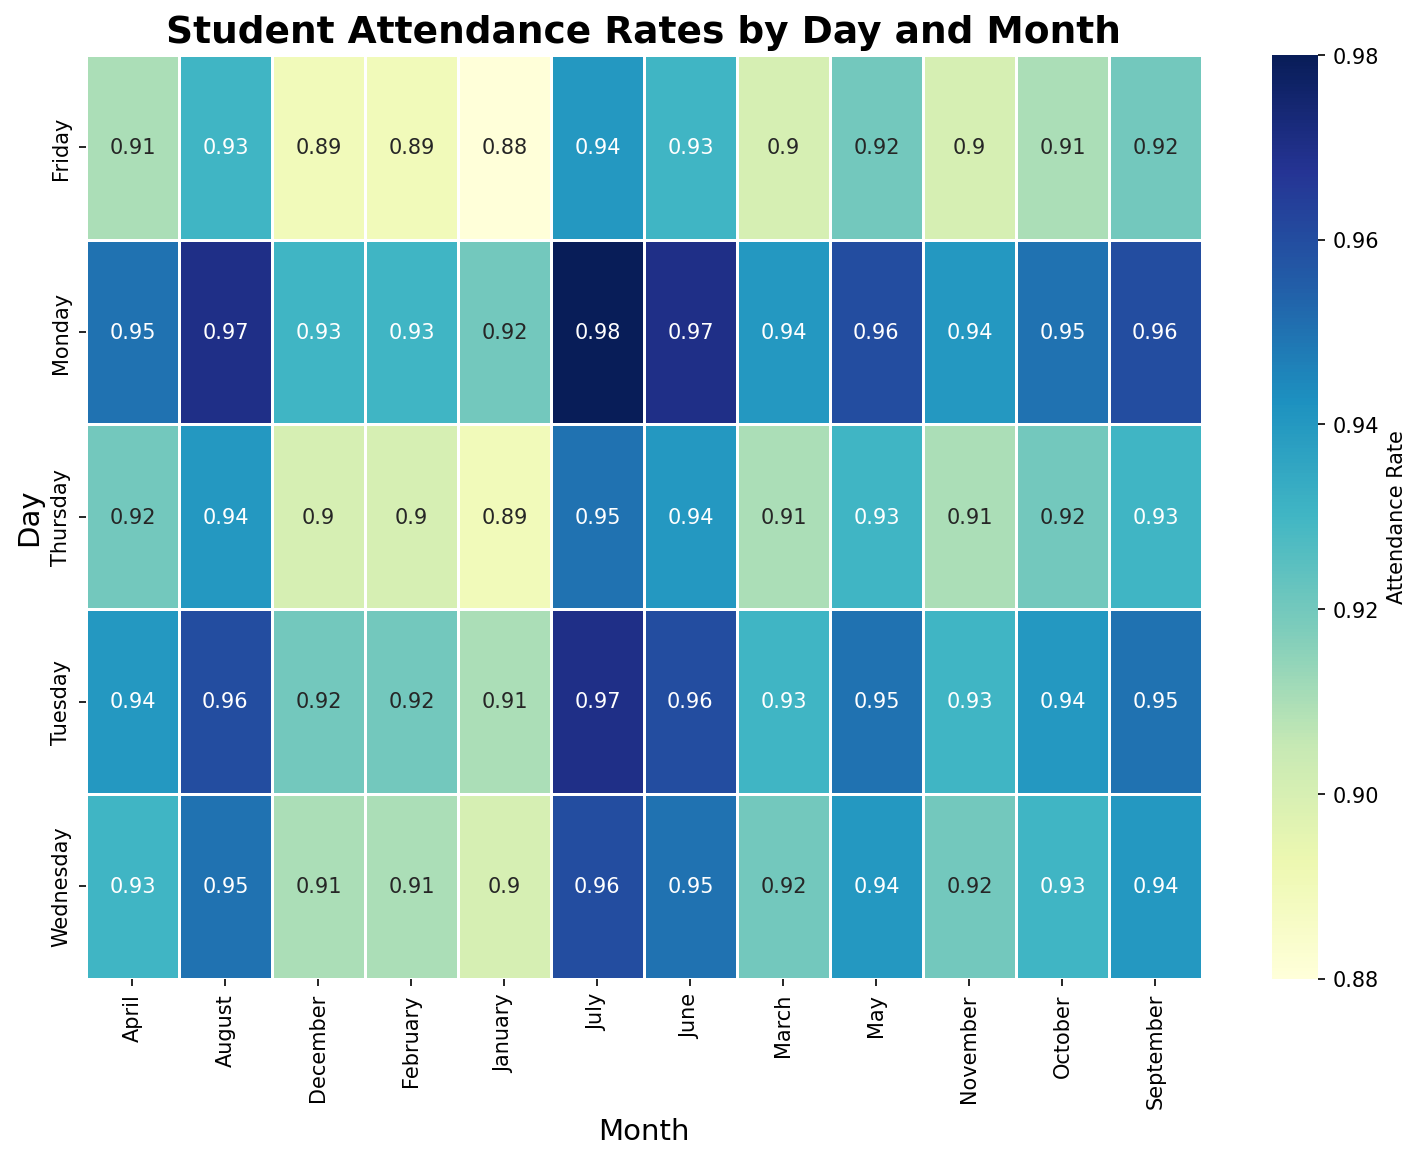What is the attendance rate on Mondays in January? Look for the data cell that corresponds to Monday and January and read the attendance rate value.
Answer: 0.92 Which month has the highest attendance rate and on what day? Look through the heatmap to find the cell with the highest attendance rate, which is colored the darkest on the scale. Identify the corresponding month and day for that cell.
Answer: July, Monday How does the attendance rate on Fridays in December compare to Fridays in March? Locate the attendance rate values for Fridays in both December and March, and compare them. December: 0.89, March: 0.90.
Answer: December is lower than March Are attendance rates generally higher at the beginning or the end of the week? Observe the color gradient and the numerical values along the days of the week. Mondays are generally lighter (higher rates) than Fridays.
Answer: Higher at the beginning of the week What is the difference in attendance rate between Tuesday in January and Tuesday in July? Identify the attendance rates for Tuesdays in January and July and subtract the January rate from the July rate. July: 0.97, January: 0.91, Difference: 0.97 - 0.91 = 0.06
Answer: 0.06 Is the attendance trend upward or downward from Monday to Friday in any given month? For each month, check if the attendance rate values decrease or increase from Monday to Friday. The trend in all months shows a decrease.
Answer: Downward What is the average attendance rate for Wednesdays in the first quarter of the year (January, February, March)? Locate the attendance rates for Wednesdays in January, February, and March, and calculate their average. January: 0.90, February: 0.91, March: 0.92, Average: (0.90 + 0.91 + 0.92)/3 = 0.91
Answer: 0.91 Which day in October has the lowest attendance rate, and what is that rate? Look for the smallest attendance rate value within October and identify the corresponding day.
Answer: Friday, 0.91 